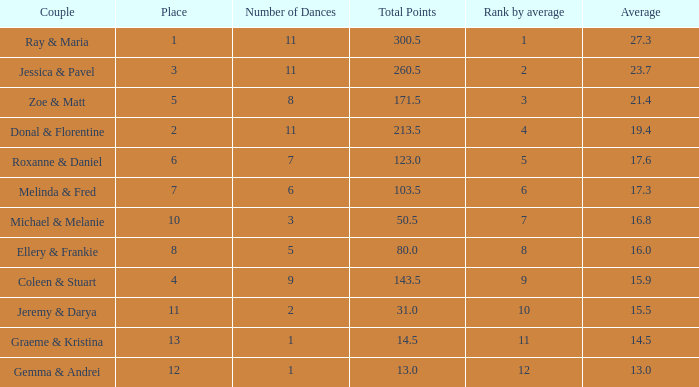What is the couples name where the average is 15.9? Coleen & Stuart. 